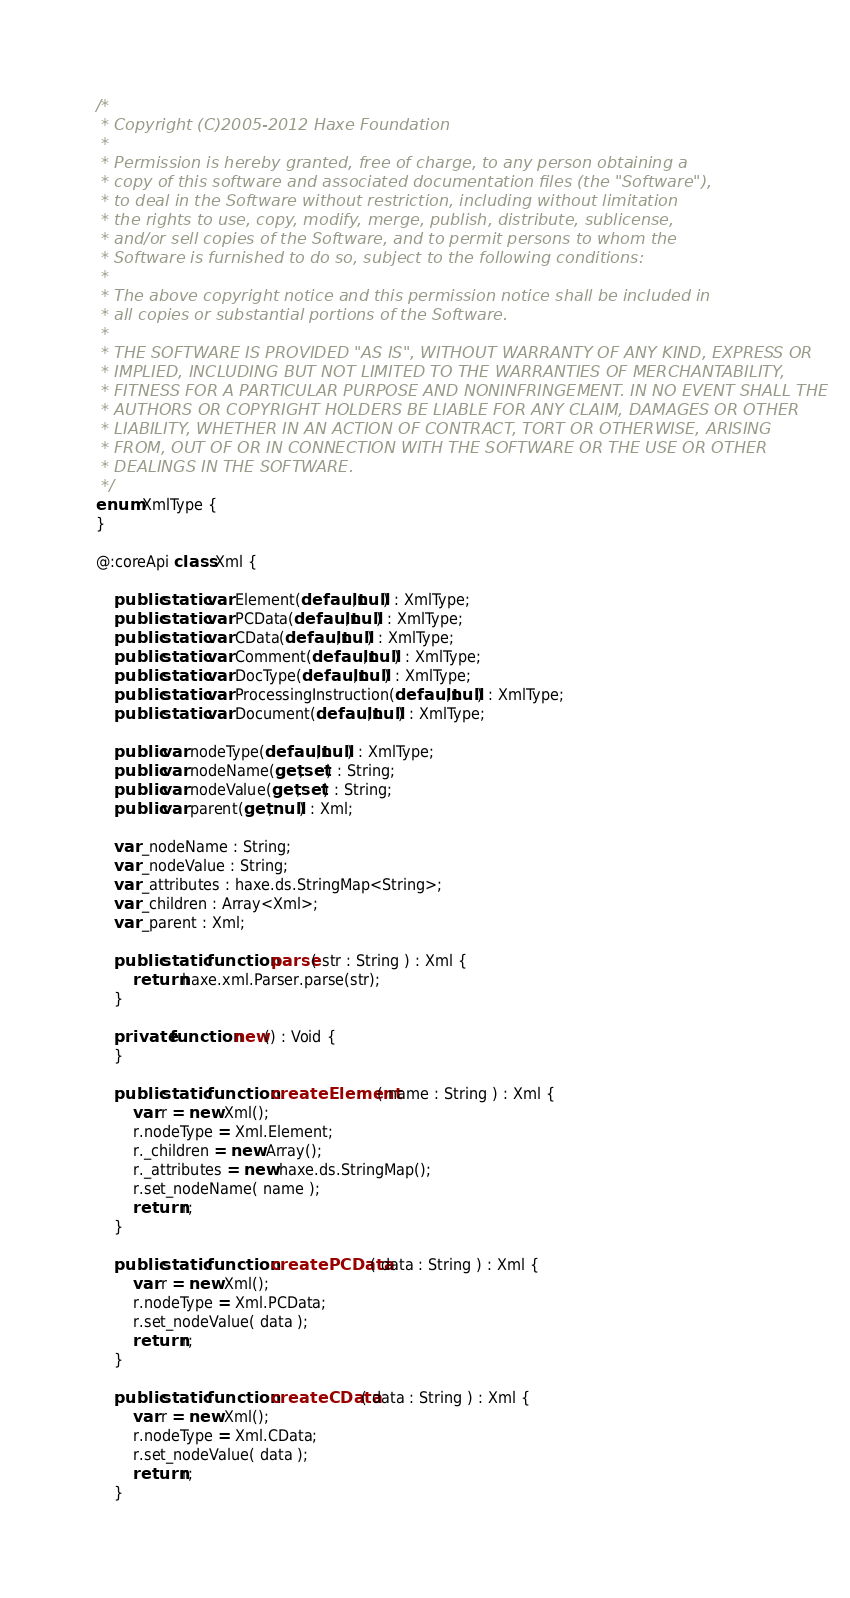Convert code to text. <code><loc_0><loc_0><loc_500><loc_500><_Haxe_>/*
 * Copyright (C)2005-2012 Haxe Foundation
 *
 * Permission is hereby granted, free of charge, to any person obtaining a
 * copy of this software and associated documentation files (the "Software"),
 * to deal in the Software without restriction, including without limitation
 * the rights to use, copy, modify, merge, publish, distribute, sublicense,
 * and/or sell copies of the Software, and to permit persons to whom the
 * Software is furnished to do so, subject to the following conditions:
 *
 * The above copyright notice and this permission notice shall be included in
 * all copies or substantial portions of the Software.
 *
 * THE SOFTWARE IS PROVIDED "AS IS", WITHOUT WARRANTY OF ANY KIND, EXPRESS OR
 * IMPLIED, INCLUDING BUT NOT LIMITED TO THE WARRANTIES OF MERCHANTABILITY,
 * FITNESS FOR A PARTICULAR PURPOSE AND NONINFRINGEMENT. IN NO EVENT SHALL THE
 * AUTHORS OR COPYRIGHT HOLDERS BE LIABLE FOR ANY CLAIM, DAMAGES OR OTHER
 * LIABILITY, WHETHER IN AN ACTION OF CONTRACT, TORT OR OTHERWISE, ARISING
 * FROM, OUT OF OR IN CONNECTION WITH THE SOFTWARE OR THE USE OR OTHER
 * DEALINGS IN THE SOFTWARE.
 */
enum XmlType {
}

@:coreApi class Xml {

	public static var Element(default,null) : XmlType;
	public static var PCData(default,null) : XmlType;
	public static var CData(default,null) : XmlType;
	public static var Comment(default,null) : XmlType;
	public static var DocType(default,null) : XmlType;
	public static var ProcessingInstruction(default,null) : XmlType;
	public static var Document(default,null) : XmlType;

	public var nodeType(default,null) : XmlType;
	public var nodeName(get,set) : String;
	public var nodeValue(get,set) : String;
	public var parent(get,null) : Xml;

	var _nodeName : String;
	var _nodeValue : String;
	var _attributes : haxe.ds.StringMap<String>;
	var _children : Array<Xml>;
	var _parent : Xml;

	public static function parse( str : String ) : Xml {
		return haxe.xml.Parser.parse(str);
	}

	private function new() : Void {
	}

	public static function createElement( name : String ) : Xml {
		var r = new Xml();
		r.nodeType = Xml.Element;
		r._children = new Array();
		r._attributes = new haxe.ds.StringMap();
		r.set_nodeName( name );
		return r;
	}

	public static function createPCData( data : String ) : Xml {
		var r = new Xml();
		r.nodeType = Xml.PCData;
		r.set_nodeValue( data );
		return r;
	}

	public static function createCData( data : String ) : Xml {
		var r = new Xml();
		r.nodeType = Xml.CData;
		r.set_nodeValue( data );
		return r;
	}
</code> 